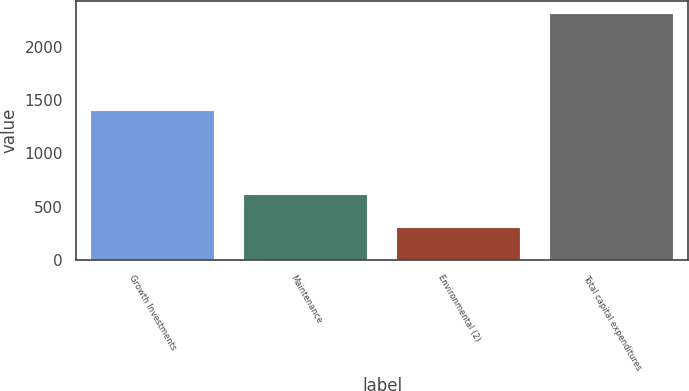Convert chart to OTSL. <chart><loc_0><loc_0><loc_500><loc_500><bar_chart><fcel>Growth Investments<fcel>Maintenance<fcel>Environmental (2)<fcel>Total capital expenditures<nl><fcel>1401<fcel>606<fcel>301<fcel>2308<nl></chart> 